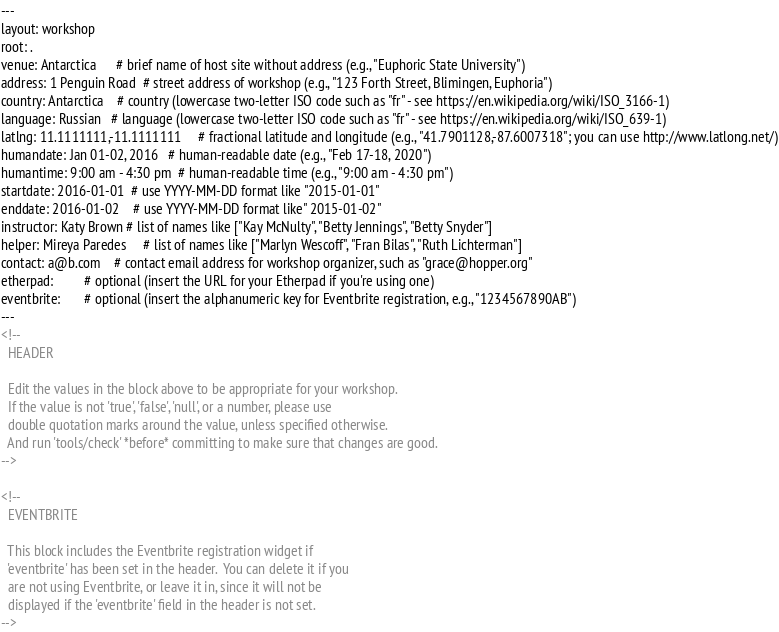Convert code to text. <code><loc_0><loc_0><loc_500><loc_500><_HTML_>---
layout: workshop
root: .
venue: Antarctica      # brief name of host site without address (e.g., "Euphoric State University")
address: 1 Penguin Road  # street address of workshop (e.g., "123 Forth Street, Blimingen, Euphoria")
country: Antarctica    # country (lowercase two-letter ISO code such as "fr" - see https://en.wikipedia.org/wiki/ISO_3166-1)
language: Russian   # language (lowercase two-letter ISO code such as "fr" - see https://en.wikipedia.org/wiki/ISO_639-1)
latlng: 11.1111111,-11.1111111     # fractional latitude and longitude (e.g., "41.7901128,-87.6007318"; you can use http://www.latlong.net/)
humandate: Jan 01-02, 2016   # human-readable date (e.g., "Feb 17-18, 2020")
humantime: 9:00 am - 4:30 pm  # human-readable time (e.g., "9:00 am - 4:30 pm")
startdate: 2016-01-01  # use YYYY-MM-DD format like "2015-01-01"
enddate: 2016-01-02    # use YYYY-MM-DD format like" 2015-01-02"
instructor: Katy Brown # list of names like ["Kay McNulty", "Betty Jennings", "Betty Snyder"]
helper: Mireya Paredes     # list of names like ["Marlyn Wescoff", "Fran Bilas", "Ruth Lichterman"]
contact: a@b.com    # contact email address for workshop organizer, such as "grace@hopper.org"
etherpad:         # optional (insert the URL for your Etherpad if you're using one)
eventbrite:       # optional (insert the alphanumeric key for Eventbrite registration, e.g., "1234567890AB")
---
<!--
  HEADER

  Edit the values in the block above to be appropriate for your workshop.
  If the value is not 'true', 'false', 'null', or a number, please use
  double quotation marks around the value, unless specified otherwise.
  And run 'tools/check' *before* committing to make sure that changes are good.
-->

<!--
  EVENTBRITE

  This block includes the Eventbrite registration widget if
  'eventbrite' has been set in the header.  You can delete it if you
  are not using Eventbrite, or leave it in, since it will not be
  displayed if the 'eventbrite' field in the header is not set.
--></code> 